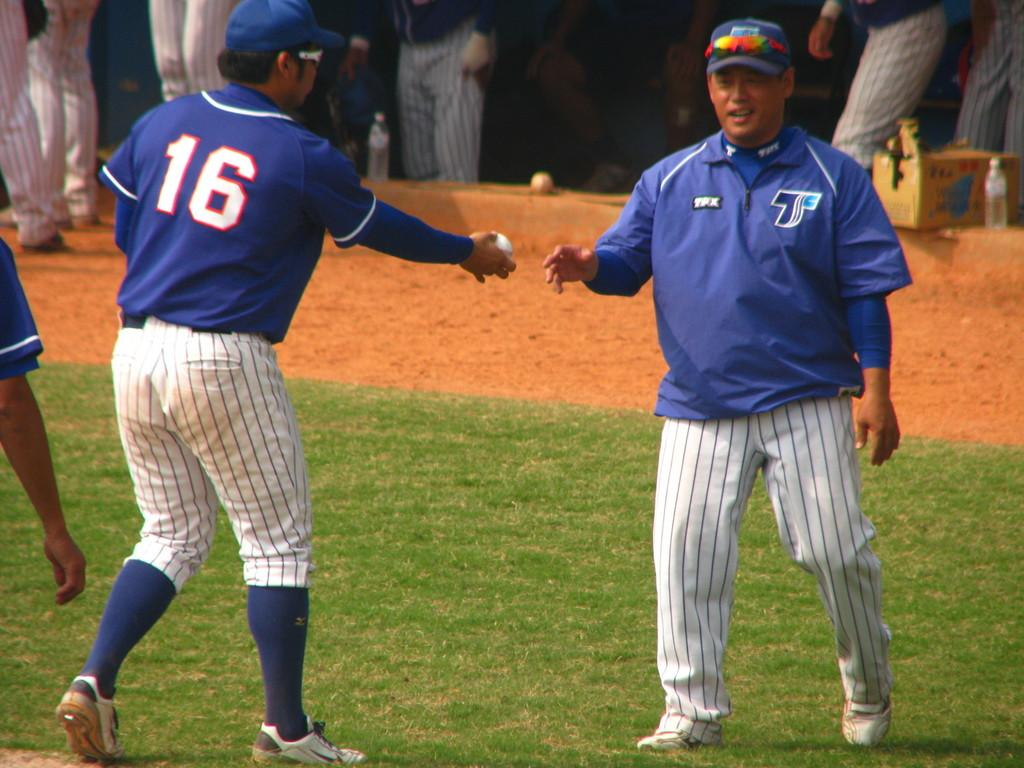<image>
Create a compact narrative representing the image presented. Player number 16 exchanges a baseball with the coach. 